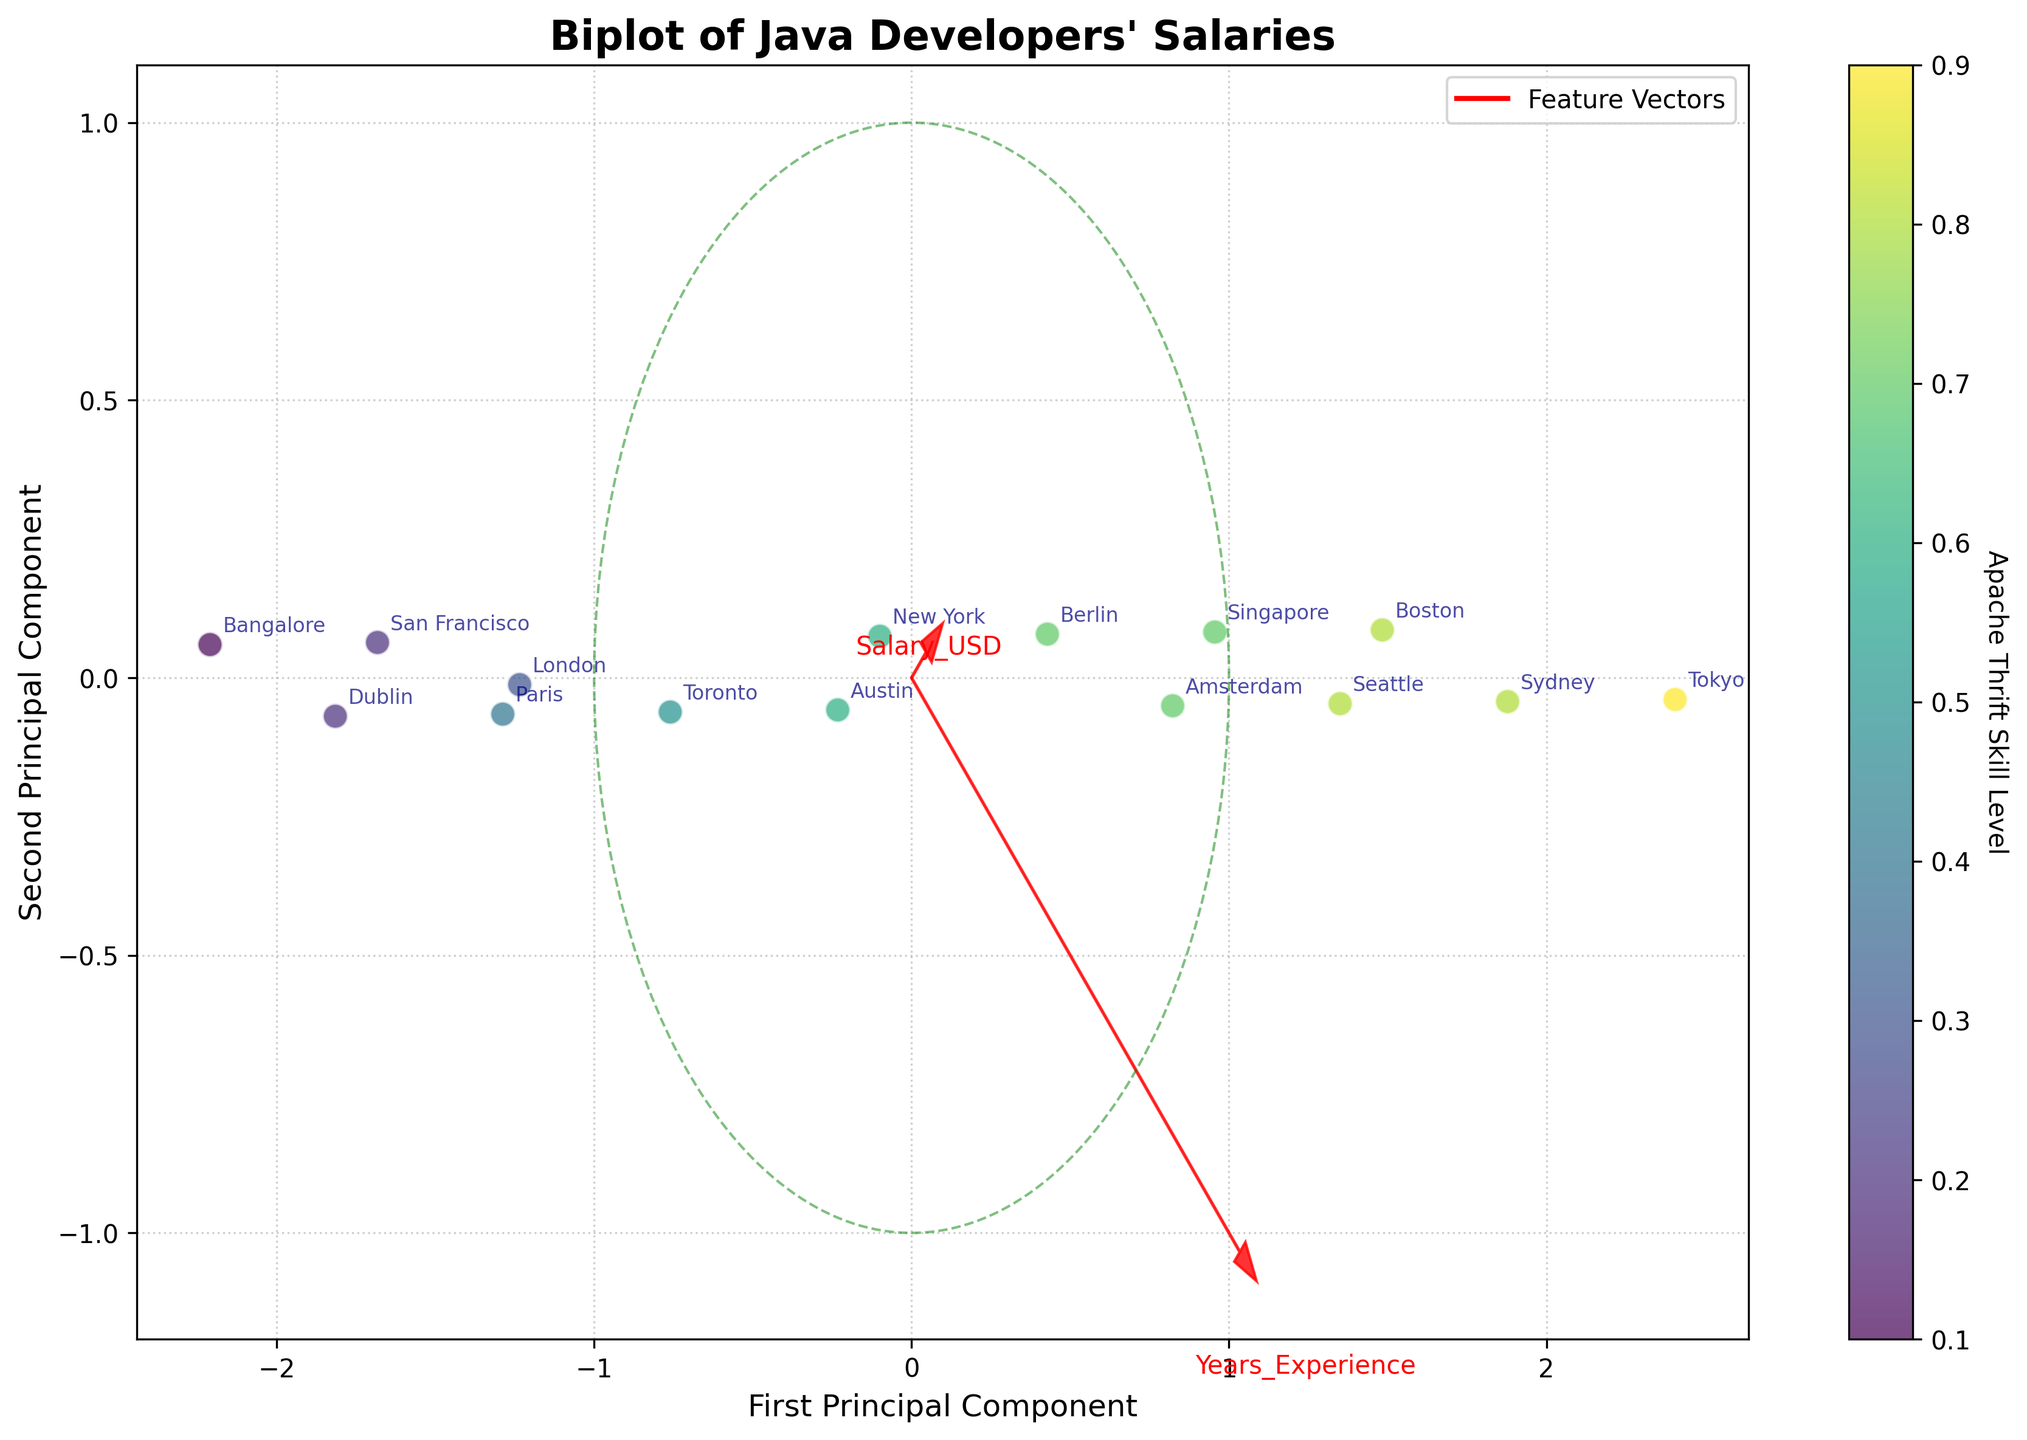What is the title of the figure? The title is typically found at the top of the figure, written in bold or larger font size to indicate the subject of the plot. It gives a brief overview of what the plot is about.
Answer: Biplot of Java Developers' Salaries How many data points are represented in the figure? By counting each point (circle) shown in the scatter plot, we can determine the number of data points. Each point correlates to an entry in the dataset.
Answer: 15 Which location has the highest Apache Thrift skill level represented in the plot? From the color gradient shown by the color bar, the point with the highest value (darkest color) corresponds to the highest Apache Thrift skill level. The labels next to the points help identify the location.
Answer: Tokyo What feature vectors are plotted in the figure? Feature vectors are represented by the red arrows extending from the origin. They show directions and relative importance of the features (Years_Experience, Salary_USD) on the principal components.
Answer: Years_Experience, Salary_USD Which principal component axis is longer based on the unit vectors? By comparing the length of the red vectors extending from the origin along the PC1 and PC2 directions, we identify the longer axis.
Answer: First Principal Component (PC1) What is the salary range for developers with around five years of experience represented in the figure? Locate the points labeled with five years of experience and read off the corresponding projected salaries on the plot. Compare their coordinates.
Answer: 90,000 USD to 95,000 USD Do developers in New York or San Francisco have higher average salaries according to this data? Find the points labeled 'New York' and 'San Francisco' and compare their associated projected salaries on the plot.
Answer: New York How is salary correlated with years of experience based on the direction of feature vectors? By observing the angles between the vectors of Salary_USD and Years_Experience, determine if they point in the same direction (positive correlation) or opposite directions (negative correlation).
Answer: Positively correlated Which location has the lowest salary and less than five years of experience? Identify the points with less than five years of experience and compare their salaries, then determine the location.
Answer: Bangalore Are developers in Berlin represented with high Apache Thrift skills and salaries? Locate the Berlin label, check its color intensity to indicate Apache Thrift skill level, and see its position relative to other salary points.
Answer: Yes 